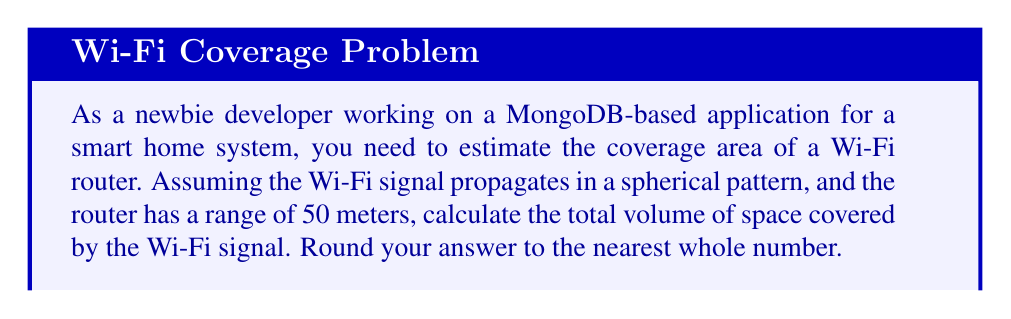Teach me how to tackle this problem. To solve this problem, we need to use the formula for the volume of a sphere. The steps are as follows:

1. Recall the formula for the volume of a sphere:
   $$V = \frac{4}{3}\pi r^3$$
   where $V$ is the volume and $r$ is the radius.

2. In this case, the radius is the range of the Wi-Fi router, which is 50 meters.

3. Substitute the value into the formula:
   $$V = \frac{4}{3}\pi (50)^3$$

4. Calculate the result:
   $$V = \frac{4}{3}\pi (125000)$$
   $$V = \frac{4}{3} (392699.0817...)$$
   $$V = 523598.7756...$$

5. Round the result to the nearest whole number:
   $$V \approx 523599$$

This calculation gives us the volume of the Wi-Fi coverage area in cubic meters.

[asy]
import three;

size(200);
currentprojection=perspective(6,3,2);

draw(surface(sphere(O,50)),paleblue+opacity(0.2));
dot(O,red);
label("Router",O,S);
draw(O--50X,dashed);
label("50m",0.5X*50,N);
[/asy]
Answer: The total volume of space covered by the Wi-Fi signal is approximately 523,599 cubic meters. 